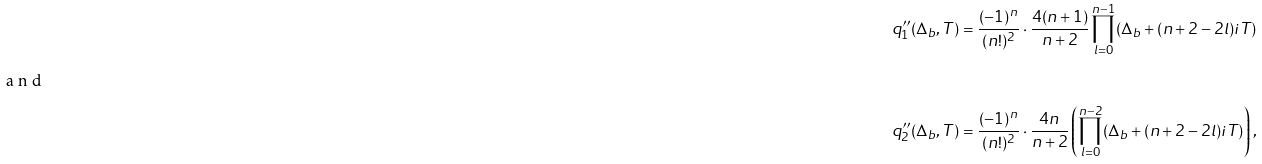<formula> <loc_0><loc_0><loc_500><loc_500>q ^ { \prime \prime } _ { 1 } ( \Delta _ { b } , T ) & = \frac { ( - 1 ) ^ { n } } { ( n ! ) ^ { 2 } } \cdot \frac { 4 ( n + 1 ) } { n + 2 } \prod _ { l = 0 } ^ { n - 1 } ( \Delta _ { b } + ( n + 2 - 2 l ) i T ) \\ \intertext { a n d } q ^ { \prime \prime } _ { 2 } ( \Delta _ { b } , T ) & = \frac { ( - 1 ) ^ { n } } { ( n ! ) ^ { 2 } } \cdot \frac { 4 n } { n + 2 } \left ( \prod _ { l = 0 } ^ { n - 2 } ( \Delta _ { b } + ( n + 2 - 2 l ) i T ) \right ) ,</formula> 